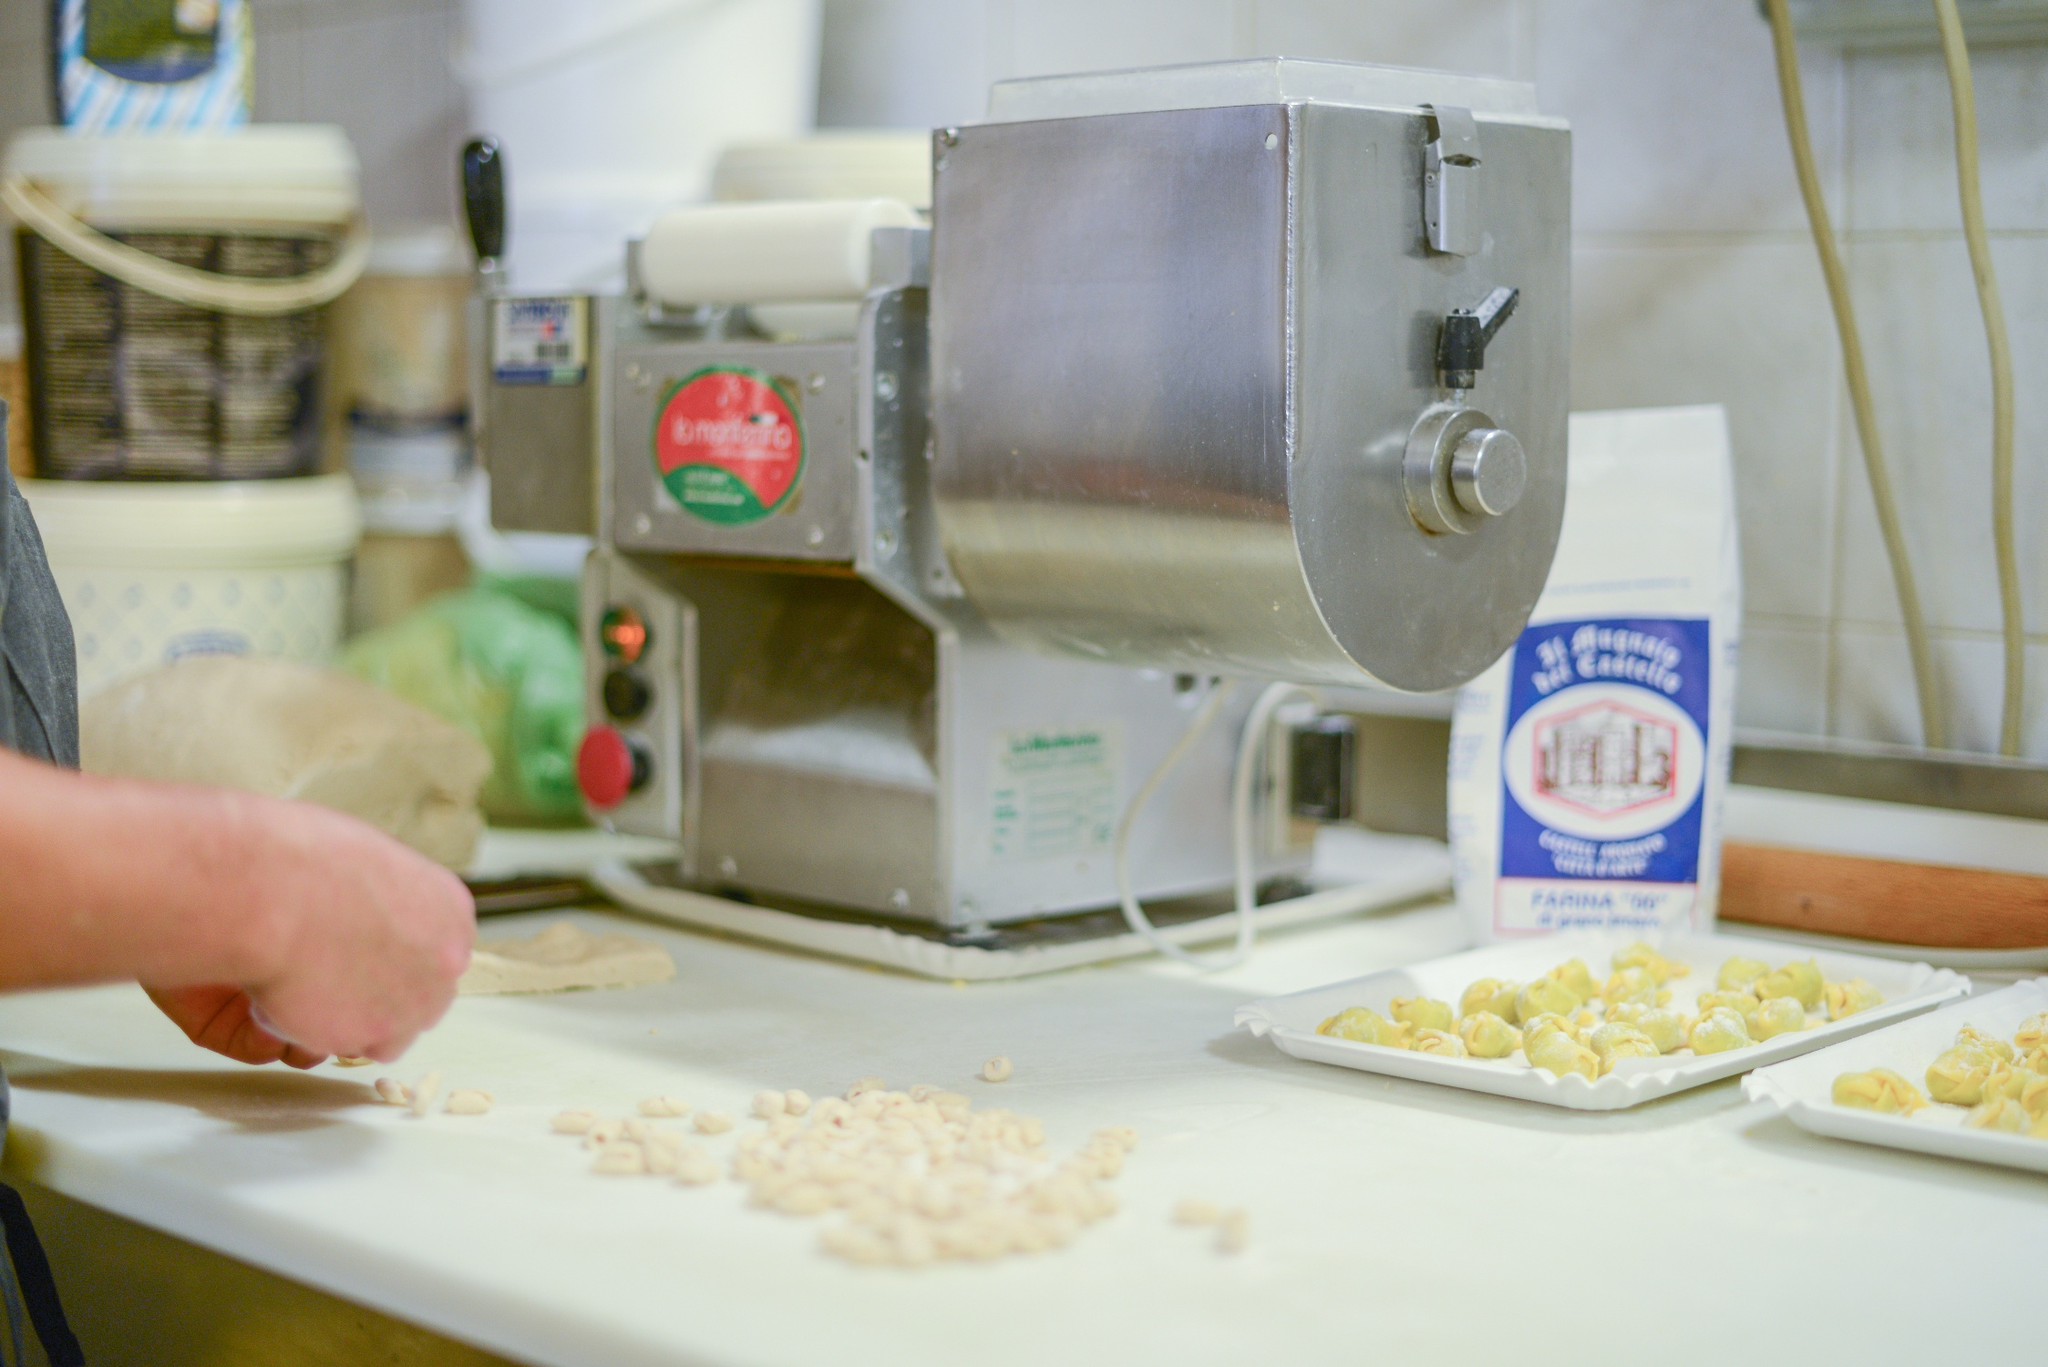Imagine you're a pasta noodle, describe your journey from dough to plate. Ah, the journey of a pasta noodle! First, I start as a humble mixture of '00' flour and water, transformed into a malleable dough by skilled hands. Kneaded to perfection, I'm then guided into the gleaming pasta machine. With each turn of the handle, I’m stretched and pressed, evolving into a delicate, thin sheet. Carefully, I’m cut into my destined shape, be it orecchiette, tortellini, or fettuccine. Placed on a tray, I dry briefly, my anticipation building. Finally, I’m plunged into boiling water, dancing in the bubbling embrace until I reach the perfect al dente. A quick toss in a rich, aromatic sauce and I’m plated, ready to delight and nourish. 